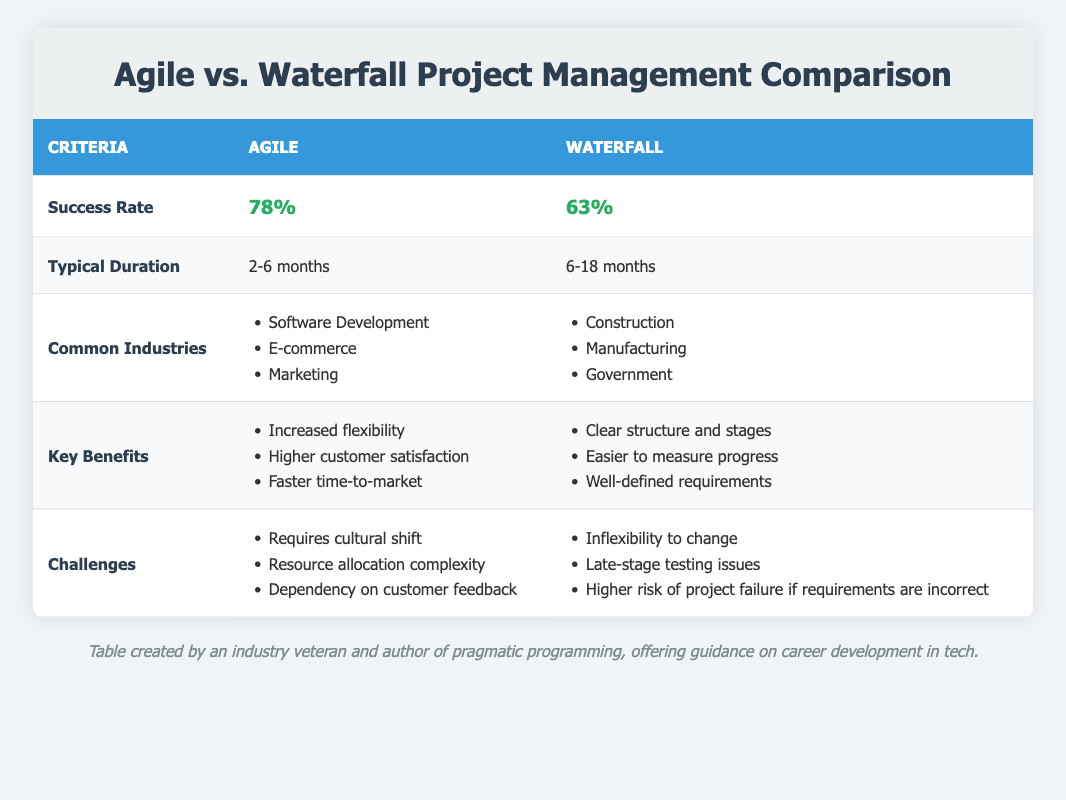What is the success rate of Agile project management? The table lists the success rate for Agile project management as 78%.
Answer: 78% What is the typical duration of a Waterfall project? According to the table, the typical duration for a Waterfall project is 6-18 months.
Answer: 6-18 months Which industries commonly use Agile project management? The table indicates that Agile is commonly used in Software Development, E-commerce, and Marketing.
Answer: Software Development, E-commerce, Marketing What are the key benefits of Agile project management? The table outlines three key benefits of Agile: increased flexibility, higher customer satisfaction, and faster time-to-market.
Answer: Increased flexibility, higher customer satisfaction, faster time-to-market What challenges does Agile project management face? The table lists the challenges of Agile as requiring a cultural shift, resource allocation complexity, and dependency on customer feedback.
Answer: Requires cultural shift, resource allocation complexity, dependency on customer feedback What is the difference in success rates between Agile and Waterfall? The success rate for Agile is 78% and for Waterfall it is 63%. The difference is calculated as 78% - 63% = 15%.
Answer: 15% Does Waterfall have a higher success rate than Agile? The table shows that Agile has a success rate of 78%, while Waterfall's is 63%. Therefore, Waterfall does not have a higher success rate.
Answer: No If a project typically takes 12 months, which methodology would it likely fall under? The typical duration for Agile is 2-6 months and for Waterfall it is 6-18 months. Since 12 months falls within the Waterfall range, it likely falls under Waterfall.
Answer: Waterfall What is the average typical duration of both Agile and Waterfall project management methods? The typical duration for Agile is 2-6 months (average 4 months) and for Waterfall is 6-18 months (average 12 months). The average is (4 + 12)/2 = 8 months.
Answer: 8 months Is it true that Agile has more benefits compared to Waterfall based on the table? Agile has three listed key benefits, while Waterfall has three as well. Therefore, it is not necessarily true that Agile has more benefits; they have the same number.
Answer: No 